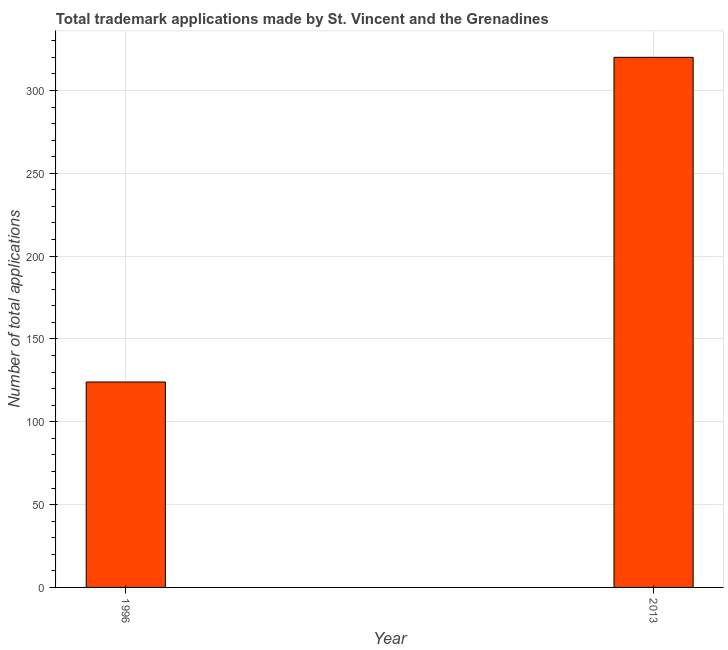Does the graph contain any zero values?
Provide a succinct answer. No. What is the title of the graph?
Your answer should be compact. Total trademark applications made by St. Vincent and the Grenadines. What is the label or title of the Y-axis?
Provide a succinct answer. Number of total applications. What is the number of trademark applications in 2013?
Offer a terse response. 320. Across all years, what is the maximum number of trademark applications?
Offer a very short reply. 320. Across all years, what is the minimum number of trademark applications?
Offer a very short reply. 124. In which year was the number of trademark applications maximum?
Give a very brief answer. 2013. In which year was the number of trademark applications minimum?
Your answer should be very brief. 1996. What is the sum of the number of trademark applications?
Your answer should be very brief. 444. What is the difference between the number of trademark applications in 1996 and 2013?
Ensure brevity in your answer.  -196. What is the average number of trademark applications per year?
Your answer should be compact. 222. What is the median number of trademark applications?
Your answer should be compact. 222. In how many years, is the number of trademark applications greater than 300 ?
Ensure brevity in your answer.  1. Do a majority of the years between 2013 and 1996 (inclusive) have number of trademark applications greater than 220 ?
Keep it short and to the point. No. What is the ratio of the number of trademark applications in 1996 to that in 2013?
Provide a short and direct response. 0.39. In how many years, is the number of trademark applications greater than the average number of trademark applications taken over all years?
Keep it short and to the point. 1. Are all the bars in the graph horizontal?
Keep it short and to the point. No. How many years are there in the graph?
Provide a short and direct response. 2. What is the difference between two consecutive major ticks on the Y-axis?
Your response must be concise. 50. What is the Number of total applications in 1996?
Your answer should be compact. 124. What is the Number of total applications in 2013?
Offer a very short reply. 320. What is the difference between the Number of total applications in 1996 and 2013?
Offer a terse response. -196. What is the ratio of the Number of total applications in 1996 to that in 2013?
Make the answer very short. 0.39. 